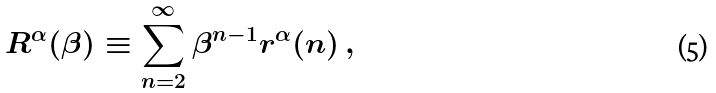<formula> <loc_0><loc_0><loc_500><loc_500>R ^ { \alpha } ( \beta ) \equiv \sum _ { n = 2 } ^ { \infty } \beta ^ { n - 1 } r ^ { \alpha } ( n ) \, ,</formula> 